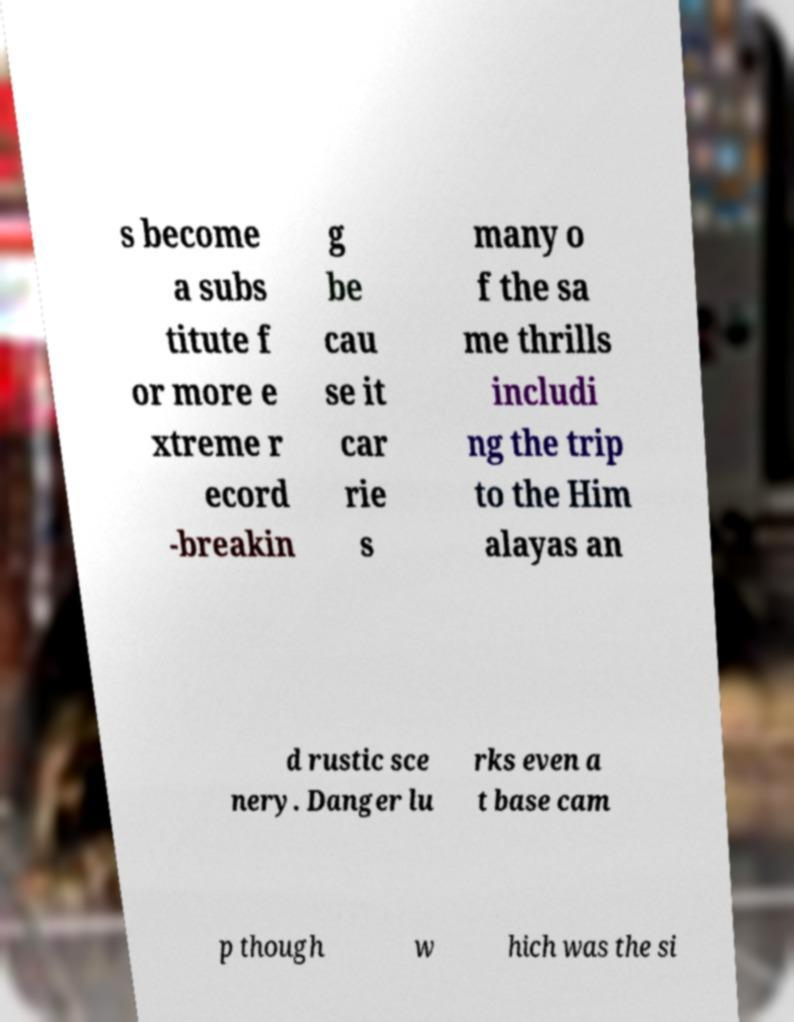Please read and relay the text visible in this image. What does it say? s become a subs titute f or more e xtreme r ecord -breakin g be cau se it car rie s many o f the sa me thrills includi ng the trip to the Him alayas an d rustic sce nery. Danger lu rks even a t base cam p though w hich was the si 